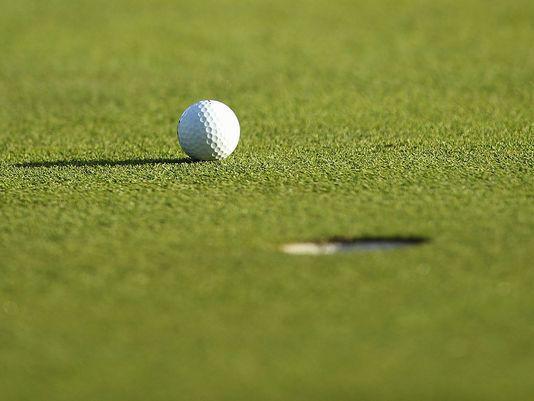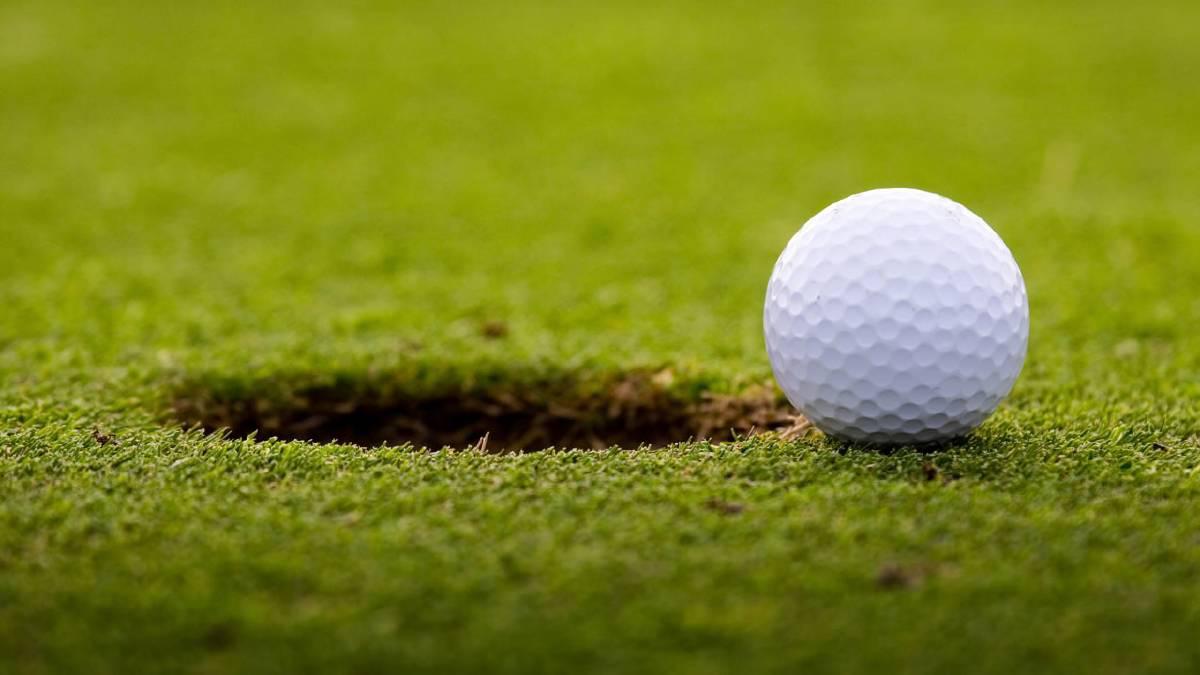The first image is the image on the left, the second image is the image on the right. For the images displayed, is the sentence "At least one image includes a ball on a golf tee." factually correct? Answer yes or no. No. The first image is the image on the left, the second image is the image on the right. For the images shown, is this caption "There are two balls near the hole in one of the images." true? Answer yes or no. No. 